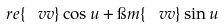<formula> <loc_0><loc_0><loc_500><loc_500>\ r e \{ \ v v \} \cos u + \i m \{ \ v v \} \sin u</formula> 